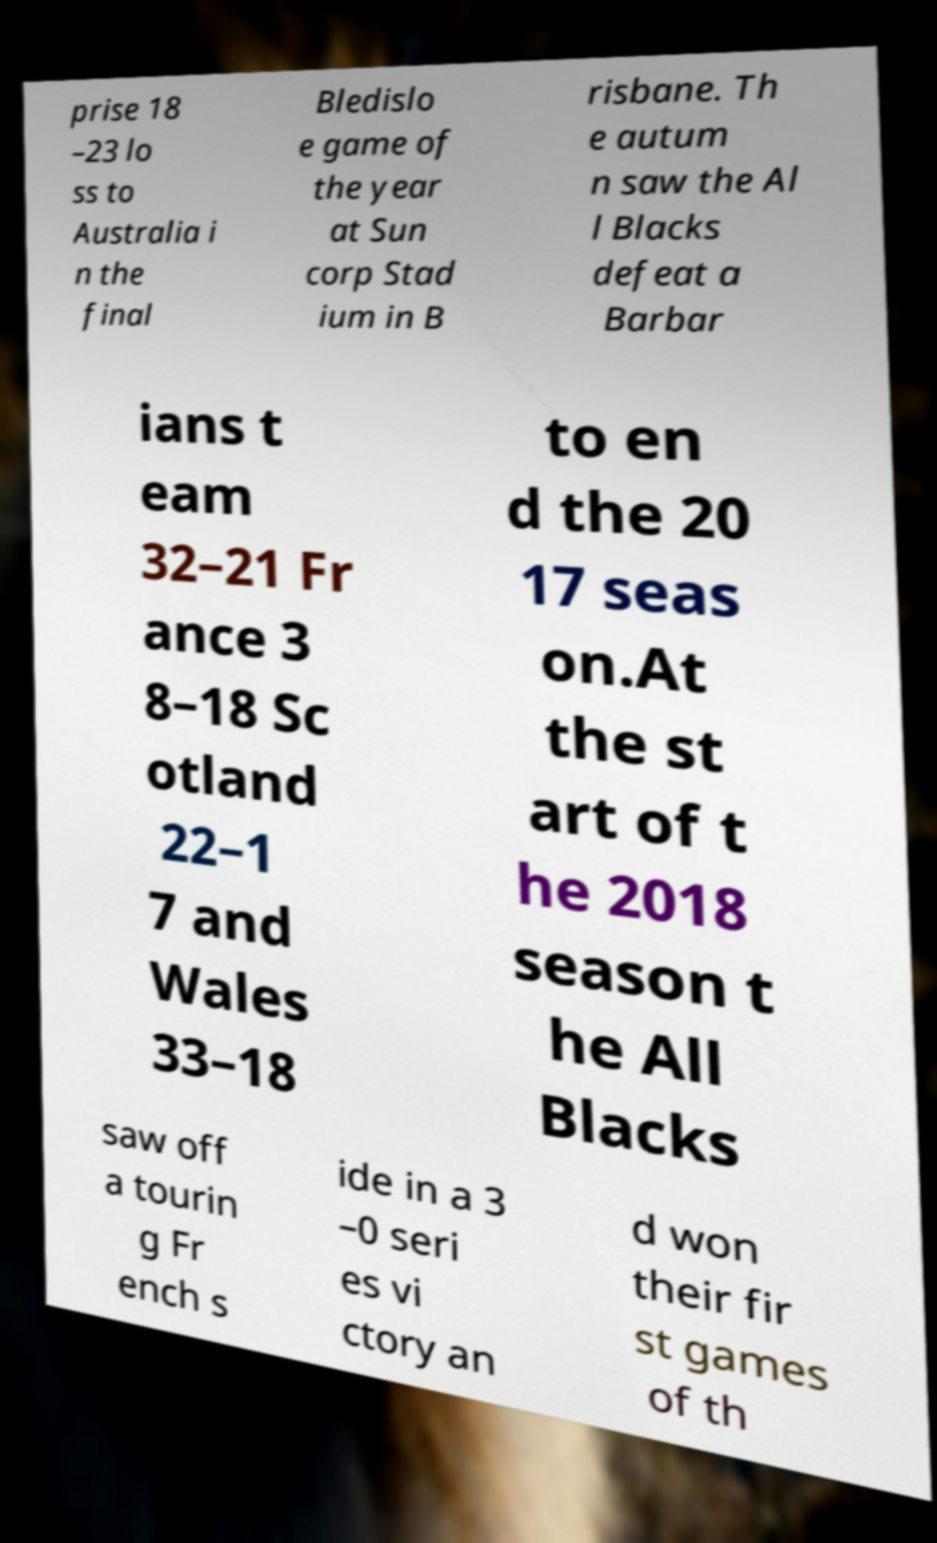Please identify and transcribe the text found in this image. prise 18 –23 lo ss to Australia i n the final Bledislo e game of the year at Sun corp Stad ium in B risbane. Th e autum n saw the Al l Blacks defeat a Barbar ians t eam 32–21 Fr ance 3 8–18 Sc otland 22–1 7 and Wales 33–18 to en d the 20 17 seas on.At the st art of t he 2018 season t he All Blacks saw off a tourin g Fr ench s ide in a 3 –0 seri es vi ctory an d won their fir st games of th 